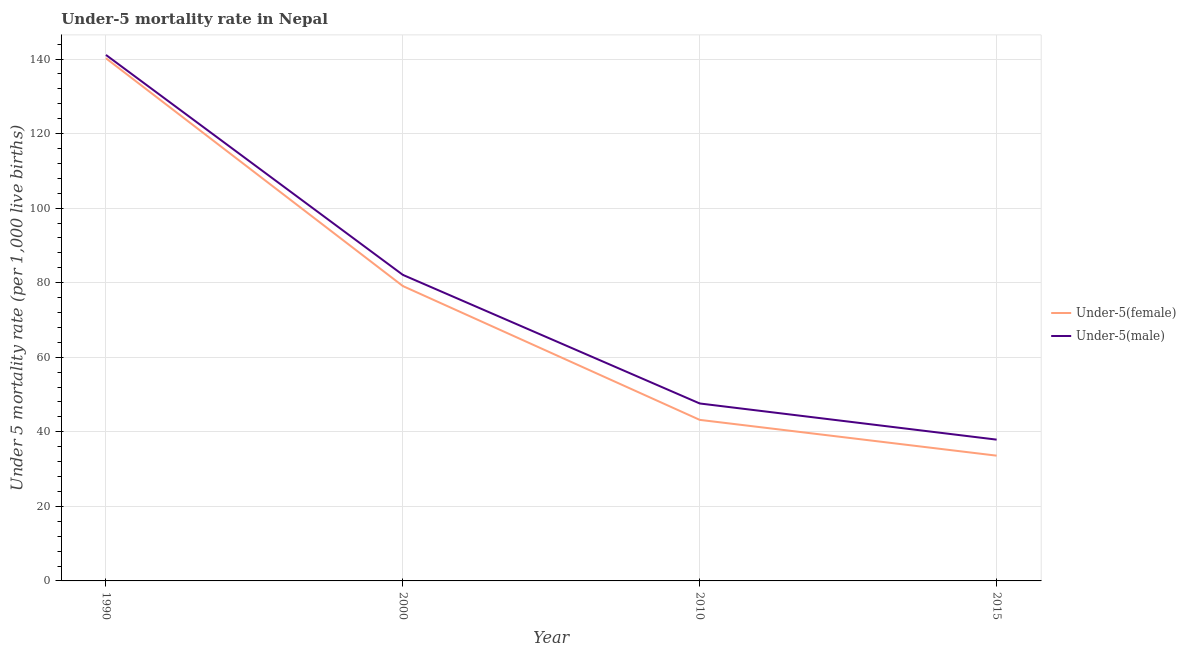How many different coloured lines are there?
Provide a succinct answer. 2. Is the number of lines equal to the number of legend labels?
Your response must be concise. Yes. What is the under-5 male mortality rate in 2015?
Offer a very short reply. 37.9. Across all years, what is the maximum under-5 female mortality rate?
Your answer should be very brief. 140.2. Across all years, what is the minimum under-5 male mortality rate?
Offer a very short reply. 37.9. In which year was the under-5 male mortality rate maximum?
Offer a terse response. 1990. In which year was the under-5 male mortality rate minimum?
Provide a succinct answer. 2015. What is the total under-5 female mortality rate in the graph?
Your answer should be compact. 296.1. What is the difference between the under-5 female mortality rate in 2010 and that in 2015?
Your answer should be very brief. 9.6. What is the difference between the under-5 male mortality rate in 2015 and the under-5 female mortality rate in 2010?
Your response must be concise. -5.3. What is the average under-5 female mortality rate per year?
Keep it short and to the point. 74.03. In how many years, is the under-5 female mortality rate greater than 16?
Give a very brief answer. 4. What is the ratio of the under-5 female mortality rate in 2000 to that in 2015?
Offer a terse response. 2.35. Is the difference between the under-5 female mortality rate in 2010 and 2015 greater than the difference between the under-5 male mortality rate in 2010 and 2015?
Offer a very short reply. No. What is the difference between the highest and the second highest under-5 female mortality rate?
Provide a short and direct response. 61.1. What is the difference between the highest and the lowest under-5 female mortality rate?
Make the answer very short. 106.6. Is the sum of the under-5 female mortality rate in 1990 and 2010 greater than the maximum under-5 male mortality rate across all years?
Offer a very short reply. Yes. Does the under-5 male mortality rate monotonically increase over the years?
Provide a succinct answer. No. Is the under-5 male mortality rate strictly less than the under-5 female mortality rate over the years?
Offer a terse response. No. How many years are there in the graph?
Ensure brevity in your answer.  4. Are the values on the major ticks of Y-axis written in scientific E-notation?
Keep it short and to the point. No. How many legend labels are there?
Keep it short and to the point. 2. What is the title of the graph?
Your answer should be very brief. Under-5 mortality rate in Nepal. Does "Nitrous oxide" appear as one of the legend labels in the graph?
Provide a succinct answer. No. What is the label or title of the X-axis?
Make the answer very short. Year. What is the label or title of the Y-axis?
Give a very brief answer. Under 5 mortality rate (per 1,0 live births). What is the Under 5 mortality rate (per 1,000 live births) of Under-5(female) in 1990?
Ensure brevity in your answer.  140.2. What is the Under 5 mortality rate (per 1,000 live births) of Under-5(male) in 1990?
Provide a short and direct response. 141.1. What is the Under 5 mortality rate (per 1,000 live births) of Under-5(female) in 2000?
Offer a very short reply. 79.1. What is the Under 5 mortality rate (per 1,000 live births) in Under-5(male) in 2000?
Keep it short and to the point. 82.1. What is the Under 5 mortality rate (per 1,000 live births) of Under-5(female) in 2010?
Your answer should be very brief. 43.2. What is the Under 5 mortality rate (per 1,000 live births) in Under-5(male) in 2010?
Your response must be concise. 47.6. What is the Under 5 mortality rate (per 1,000 live births) in Under-5(female) in 2015?
Offer a very short reply. 33.6. What is the Under 5 mortality rate (per 1,000 live births) of Under-5(male) in 2015?
Provide a succinct answer. 37.9. Across all years, what is the maximum Under 5 mortality rate (per 1,000 live births) of Under-5(female)?
Give a very brief answer. 140.2. Across all years, what is the maximum Under 5 mortality rate (per 1,000 live births) of Under-5(male)?
Your answer should be very brief. 141.1. Across all years, what is the minimum Under 5 mortality rate (per 1,000 live births) of Under-5(female)?
Your response must be concise. 33.6. Across all years, what is the minimum Under 5 mortality rate (per 1,000 live births) of Under-5(male)?
Offer a terse response. 37.9. What is the total Under 5 mortality rate (per 1,000 live births) of Under-5(female) in the graph?
Your answer should be very brief. 296.1. What is the total Under 5 mortality rate (per 1,000 live births) of Under-5(male) in the graph?
Make the answer very short. 308.7. What is the difference between the Under 5 mortality rate (per 1,000 live births) of Under-5(female) in 1990 and that in 2000?
Make the answer very short. 61.1. What is the difference between the Under 5 mortality rate (per 1,000 live births) of Under-5(female) in 1990 and that in 2010?
Your response must be concise. 97. What is the difference between the Under 5 mortality rate (per 1,000 live births) of Under-5(male) in 1990 and that in 2010?
Give a very brief answer. 93.5. What is the difference between the Under 5 mortality rate (per 1,000 live births) in Under-5(female) in 1990 and that in 2015?
Provide a short and direct response. 106.6. What is the difference between the Under 5 mortality rate (per 1,000 live births) in Under-5(male) in 1990 and that in 2015?
Offer a very short reply. 103.2. What is the difference between the Under 5 mortality rate (per 1,000 live births) of Under-5(female) in 2000 and that in 2010?
Provide a succinct answer. 35.9. What is the difference between the Under 5 mortality rate (per 1,000 live births) in Under-5(male) in 2000 and that in 2010?
Offer a terse response. 34.5. What is the difference between the Under 5 mortality rate (per 1,000 live births) in Under-5(female) in 2000 and that in 2015?
Provide a succinct answer. 45.5. What is the difference between the Under 5 mortality rate (per 1,000 live births) in Under-5(male) in 2000 and that in 2015?
Your answer should be compact. 44.2. What is the difference between the Under 5 mortality rate (per 1,000 live births) in Under-5(female) in 1990 and the Under 5 mortality rate (per 1,000 live births) in Under-5(male) in 2000?
Offer a terse response. 58.1. What is the difference between the Under 5 mortality rate (per 1,000 live births) in Under-5(female) in 1990 and the Under 5 mortality rate (per 1,000 live births) in Under-5(male) in 2010?
Your answer should be compact. 92.6. What is the difference between the Under 5 mortality rate (per 1,000 live births) in Under-5(female) in 1990 and the Under 5 mortality rate (per 1,000 live births) in Under-5(male) in 2015?
Give a very brief answer. 102.3. What is the difference between the Under 5 mortality rate (per 1,000 live births) of Under-5(female) in 2000 and the Under 5 mortality rate (per 1,000 live births) of Under-5(male) in 2010?
Make the answer very short. 31.5. What is the difference between the Under 5 mortality rate (per 1,000 live births) of Under-5(female) in 2000 and the Under 5 mortality rate (per 1,000 live births) of Under-5(male) in 2015?
Your response must be concise. 41.2. What is the average Under 5 mortality rate (per 1,000 live births) in Under-5(female) per year?
Give a very brief answer. 74.03. What is the average Under 5 mortality rate (per 1,000 live births) in Under-5(male) per year?
Your response must be concise. 77.17. In the year 2015, what is the difference between the Under 5 mortality rate (per 1,000 live births) in Under-5(female) and Under 5 mortality rate (per 1,000 live births) in Under-5(male)?
Give a very brief answer. -4.3. What is the ratio of the Under 5 mortality rate (per 1,000 live births) of Under-5(female) in 1990 to that in 2000?
Your response must be concise. 1.77. What is the ratio of the Under 5 mortality rate (per 1,000 live births) of Under-5(male) in 1990 to that in 2000?
Your answer should be compact. 1.72. What is the ratio of the Under 5 mortality rate (per 1,000 live births) in Under-5(female) in 1990 to that in 2010?
Your response must be concise. 3.25. What is the ratio of the Under 5 mortality rate (per 1,000 live births) of Under-5(male) in 1990 to that in 2010?
Make the answer very short. 2.96. What is the ratio of the Under 5 mortality rate (per 1,000 live births) in Under-5(female) in 1990 to that in 2015?
Offer a terse response. 4.17. What is the ratio of the Under 5 mortality rate (per 1,000 live births) of Under-5(male) in 1990 to that in 2015?
Your response must be concise. 3.72. What is the ratio of the Under 5 mortality rate (per 1,000 live births) of Under-5(female) in 2000 to that in 2010?
Your response must be concise. 1.83. What is the ratio of the Under 5 mortality rate (per 1,000 live births) of Under-5(male) in 2000 to that in 2010?
Your answer should be very brief. 1.72. What is the ratio of the Under 5 mortality rate (per 1,000 live births) in Under-5(female) in 2000 to that in 2015?
Your response must be concise. 2.35. What is the ratio of the Under 5 mortality rate (per 1,000 live births) in Under-5(male) in 2000 to that in 2015?
Your answer should be very brief. 2.17. What is the ratio of the Under 5 mortality rate (per 1,000 live births) in Under-5(male) in 2010 to that in 2015?
Make the answer very short. 1.26. What is the difference between the highest and the second highest Under 5 mortality rate (per 1,000 live births) in Under-5(female)?
Offer a terse response. 61.1. What is the difference between the highest and the lowest Under 5 mortality rate (per 1,000 live births) of Under-5(female)?
Your answer should be very brief. 106.6. What is the difference between the highest and the lowest Under 5 mortality rate (per 1,000 live births) of Under-5(male)?
Your response must be concise. 103.2. 